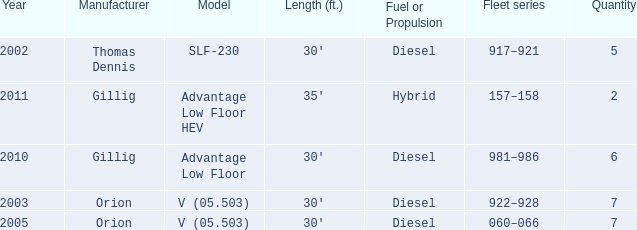Specify the series of fleets with a count of 917–921. 